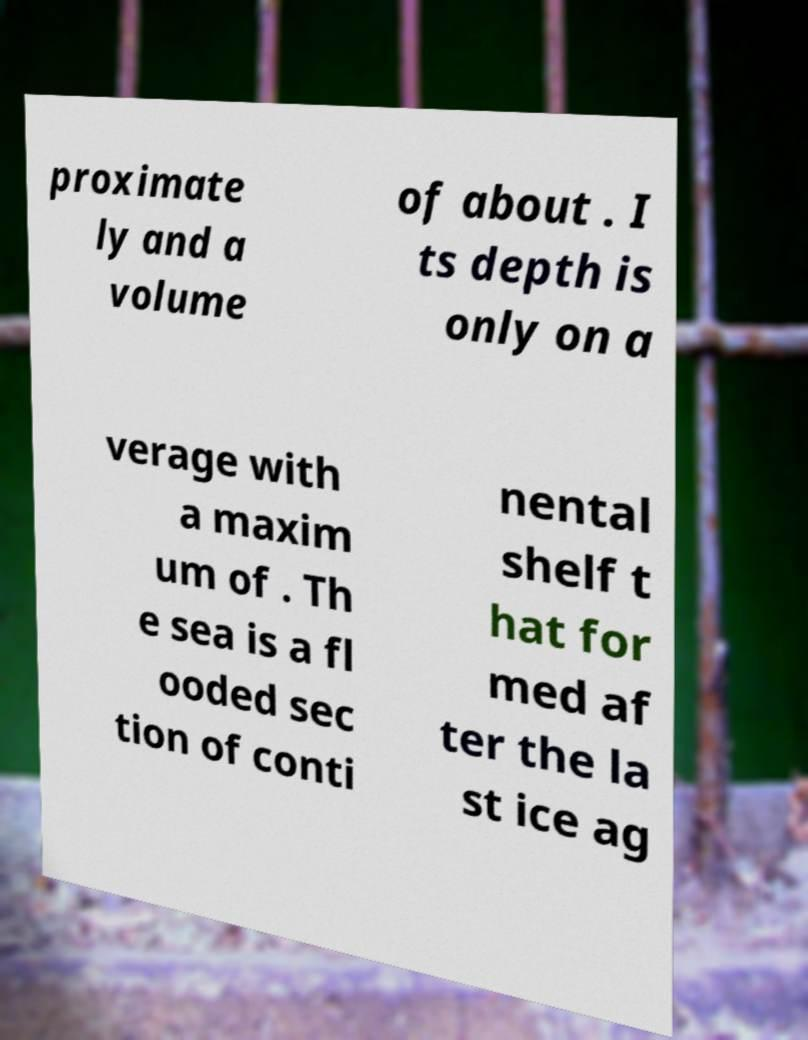Can you accurately transcribe the text from the provided image for me? proximate ly and a volume of about . I ts depth is only on a verage with a maxim um of . Th e sea is a fl ooded sec tion of conti nental shelf t hat for med af ter the la st ice ag 